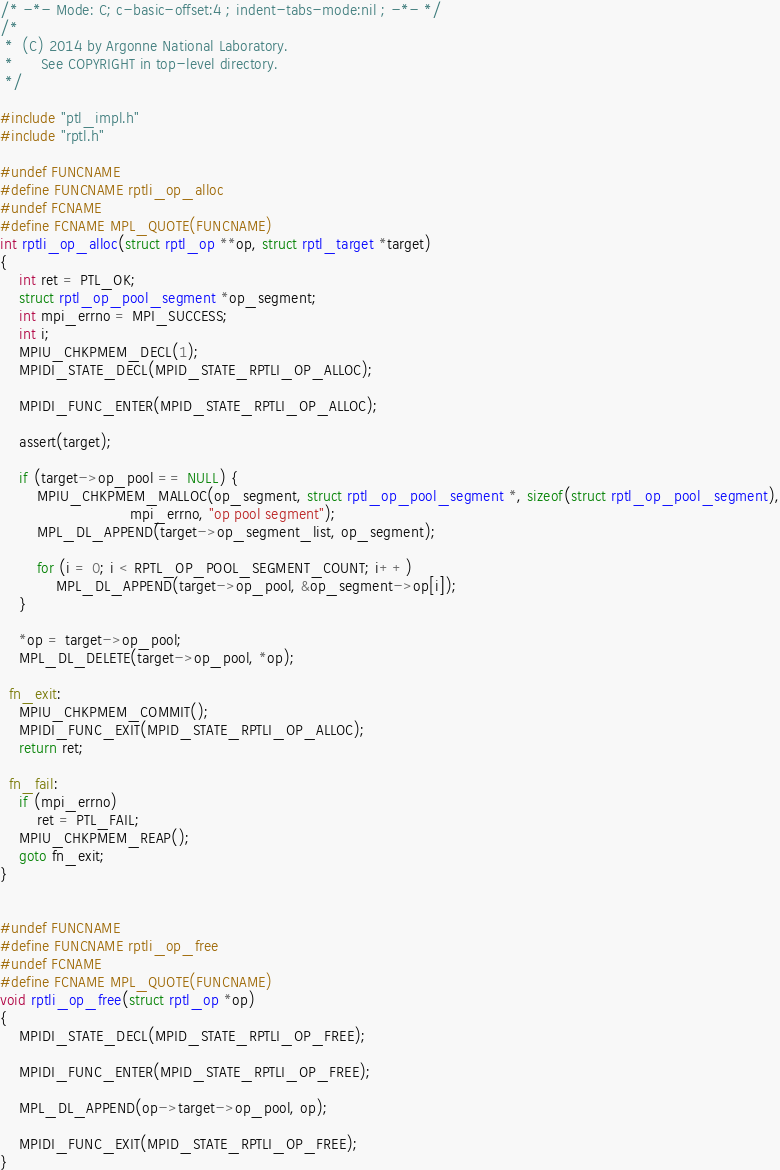<code> <loc_0><loc_0><loc_500><loc_500><_C_>/* -*- Mode: C; c-basic-offset:4 ; indent-tabs-mode:nil ; -*- */
/*
 *  (C) 2014 by Argonne National Laboratory.
 *      See COPYRIGHT in top-level directory.
 */

#include "ptl_impl.h"
#include "rptl.h"

#undef FUNCNAME
#define FUNCNAME rptli_op_alloc
#undef FCNAME
#define FCNAME MPL_QUOTE(FUNCNAME)
int rptli_op_alloc(struct rptl_op **op, struct rptl_target *target)
{
    int ret = PTL_OK;
    struct rptl_op_pool_segment *op_segment;
    int mpi_errno = MPI_SUCCESS;
    int i;
    MPIU_CHKPMEM_DECL(1);
    MPIDI_STATE_DECL(MPID_STATE_RPTLI_OP_ALLOC);

    MPIDI_FUNC_ENTER(MPID_STATE_RPTLI_OP_ALLOC);

    assert(target);

    if (target->op_pool == NULL) {
        MPIU_CHKPMEM_MALLOC(op_segment, struct rptl_op_pool_segment *, sizeof(struct rptl_op_pool_segment),
                            mpi_errno, "op pool segment");
        MPL_DL_APPEND(target->op_segment_list, op_segment);

        for (i = 0; i < RPTL_OP_POOL_SEGMENT_COUNT; i++)
            MPL_DL_APPEND(target->op_pool, &op_segment->op[i]);
    }

    *op = target->op_pool;
    MPL_DL_DELETE(target->op_pool, *op);

  fn_exit:
    MPIU_CHKPMEM_COMMIT();
    MPIDI_FUNC_EXIT(MPID_STATE_RPTLI_OP_ALLOC);
    return ret;

  fn_fail:
    if (mpi_errno)
        ret = PTL_FAIL;
    MPIU_CHKPMEM_REAP();
    goto fn_exit;
}


#undef FUNCNAME
#define FUNCNAME rptli_op_free
#undef FCNAME
#define FCNAME MPL_QUOTE(FUNCNAME)
void rptli_op_free(struct rptl_op *op)
{
    MPIDI_STATE_DECL(MPID_STATE_RPTLI_OP_FREE);

    MPIDI_FUNC_ENTER(MPID_STATE_RPTLI_OP_FREE);

    MPL_DL_APPEND(op->target->op_pool, op);

    MPIDI_FUNC_EXIT(MPID_STATE_RPTLI_OP_FREE);
}
</code> 